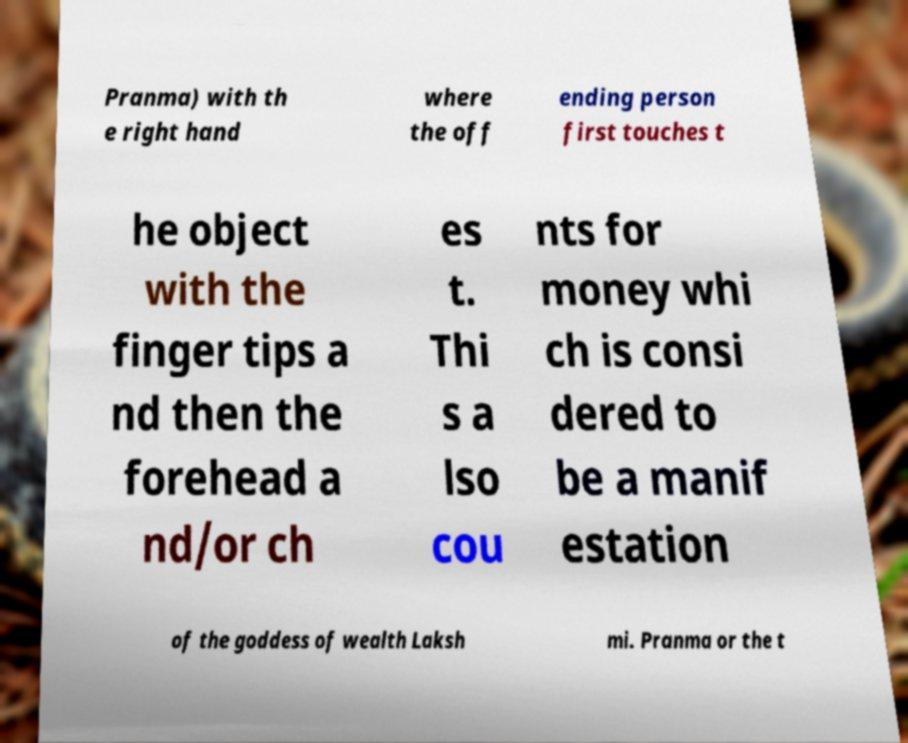Can you accurately transcribe the text from the provided image for me? Pranma) with th e right hand where the off ending person first touches t he object with the finger tips a nd then the forehead a nd/or ch es t. Thi s a lso cou nts for money whi ch is consi dered to be a manif estation of the goddess of wealth Laksh mi. Pranma or the t 